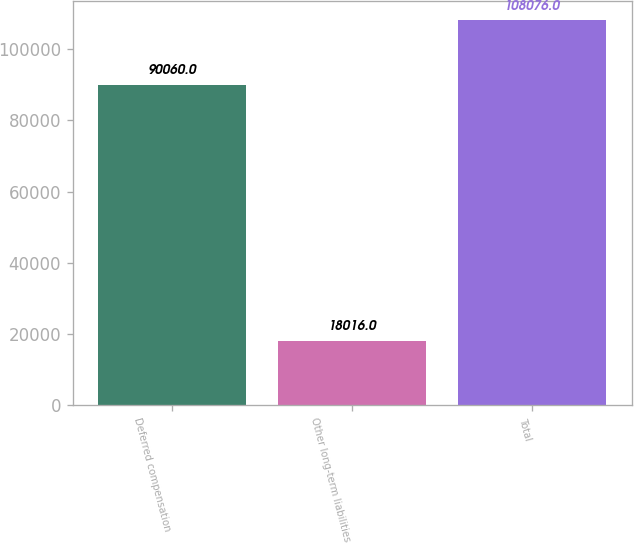Convert chart to OTSL. <chart><loc_0><loc_0><loc_500><loc_500><bar_chart><fcel>Deferred compensation<fcel>Other long-term liabilities<fcel>Total<nl><fcel>90060<fcel>18016<fcel>108076<nl></chart> 